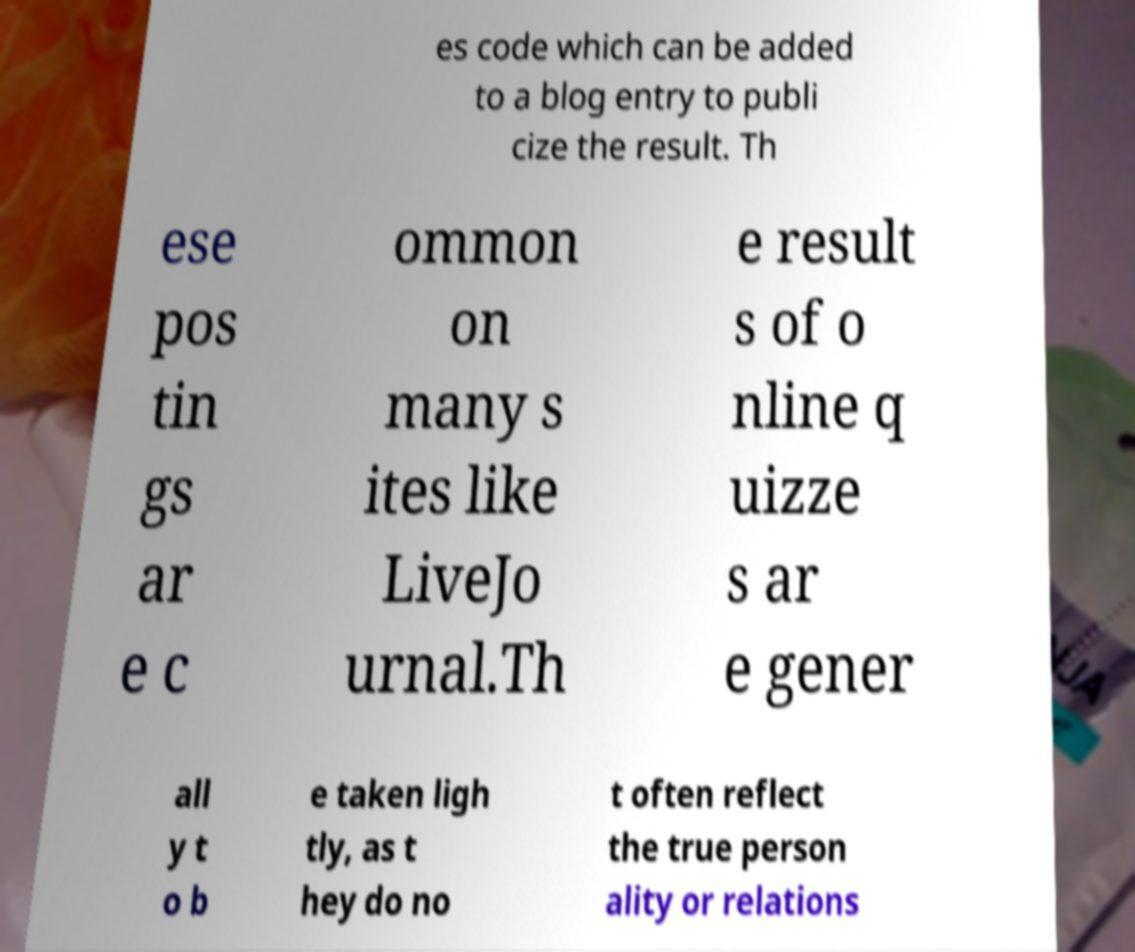Could you extract and type out the text from this image? es code which can be added to a blog entry to publi cize the result. Th ese pos tin gs ar e c ommon on many s ites like LiveJo urnal.Th e result s of o nline q uizze s ar e gener all y t o b e taken ligh tly, as t hey do no t often reflect the true person ality or relations 